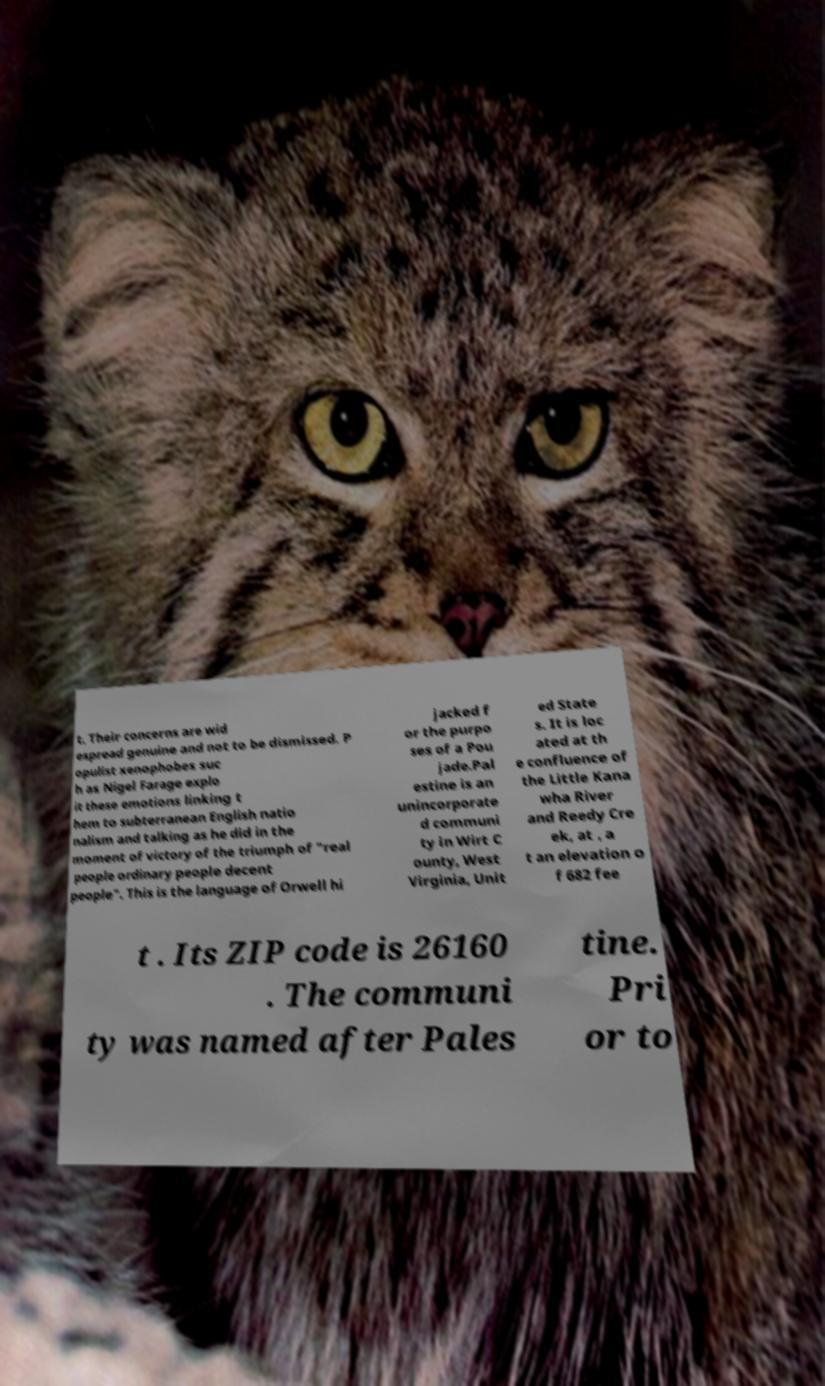There's text embedded in this image that I need extracted. Can you transcribe it verbatim? t. Their concerns are wid espread genuine and not to be dismissed. P opulist xenophobes suc h as Nigel Farage explo it these emotions linking t hem to subterranean English natio nalism and talking as he did in the moment of victory of the triumph of "real people ordinary people decent people". This is the language of Orwell hi jacked f or the purpo ses of a Pou jade.Pal estine is an unincorporate d communi ty in Wirt C ounty, West Virginia, Unit ed State s. It is loc ated at th e confluence of the Little Kana wha River and Reedy Cre ek, at , a t an elevation o f 682 fee t . Its ZIP code is 26160 . The communi ty was named after Pales tine. Pri or to 